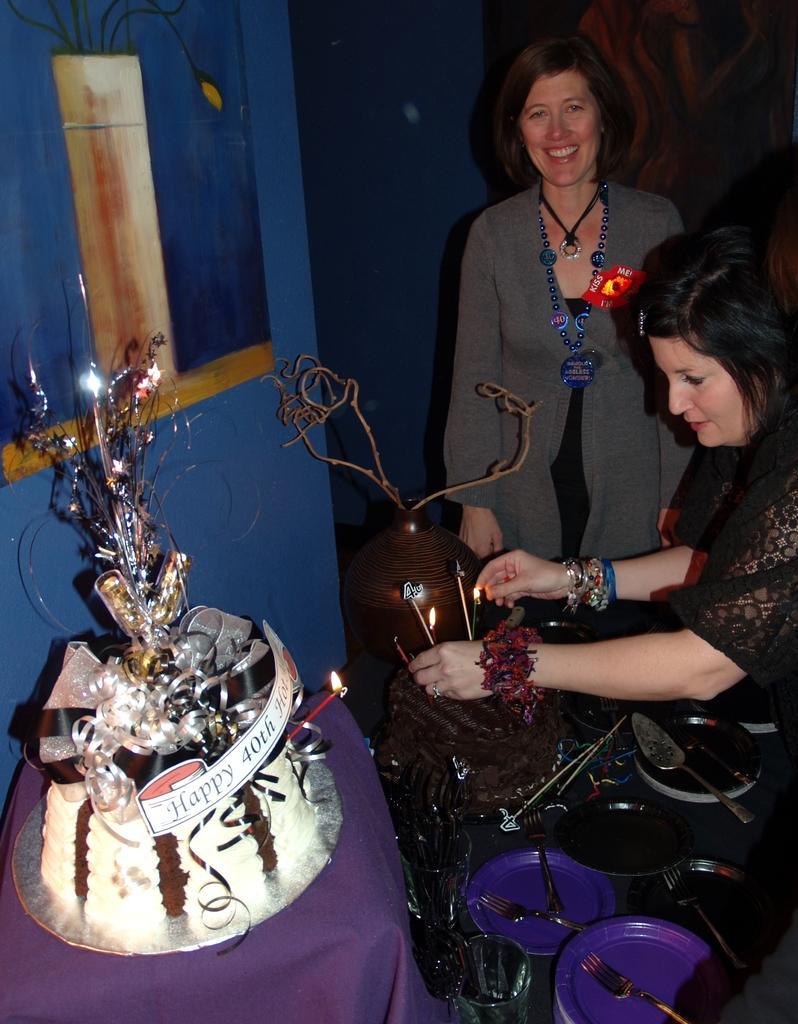Describe this image in one or two sentences. On the right side of the image we can see persons, candles, plates, spoons, forks, glasses placed on the table. On the left side of the image we can see cake, candle, painting and wall. 